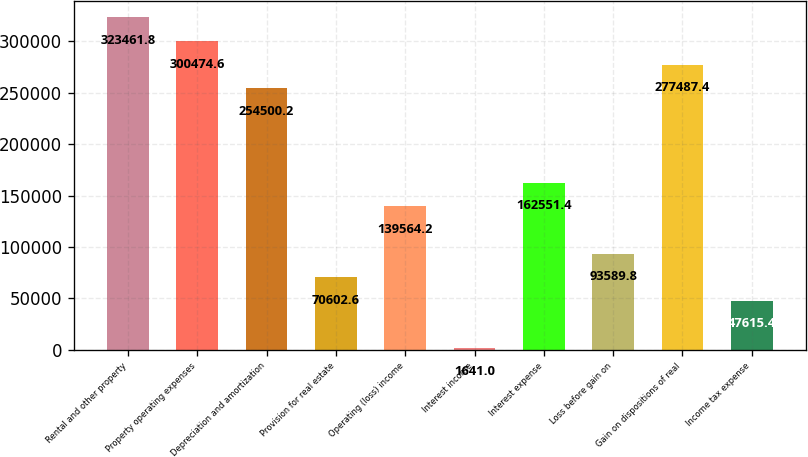Convert chart to OTSL. <chart><loc_0><loc_0><loc_500><loc_500><bar_chart><fcel>Rental and other property<fcel>Property operating expenses<fcel>Depreciation and amortization<fcel>Provision for real estate<fcel>Operating (loss) income<fcel>Interest income<fcel>Interest expense<fcel>Loss before gain on<fcel>Gain on dispositions of real<fcel>Income tax expense<nl><fcel>323462<fcel>300475<fcel>254500<fcel>70602.6<fcel>139564<fcel>1641<fcel>162551<fcel>93589.8<fcel>277487<fcel>47615.4<nl></chart> 